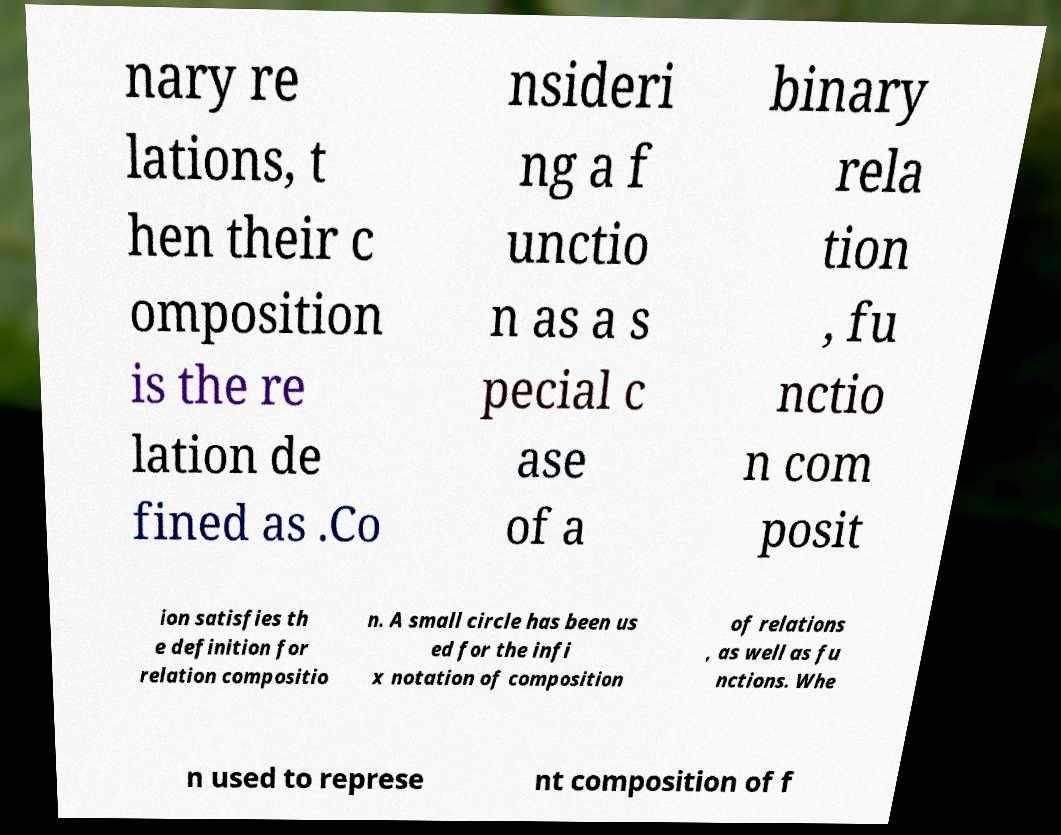For documentation purposes, I need the text within this image transcribed. Could you provide that? nary re lations, t hen their c omposition is the re lation de fined as .Co nsideri ng a f unctio n as a s pecial c ase of a binary rela tion , fu nctio n com posit ion satisfies th e definition for relation compositio n. A small circle has been us ed for the infi x notation of composition of relations , as well as fu nctions. Whe n used to represe nt composition of f 